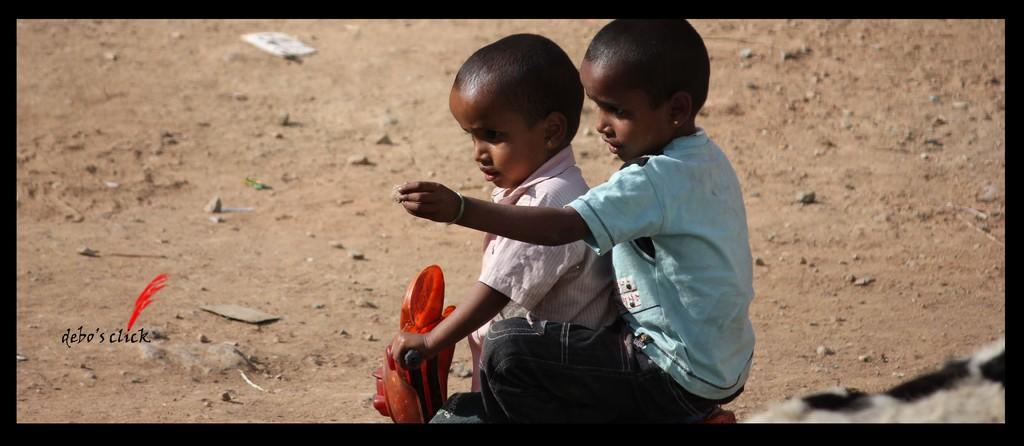What type of terrain is visible in the image? There is sand in the image. What other elements can be seen in the terrain? There are stones in the image. How many kids are present in the image? There are two kids in the image. What are the kids doing in the image? The kids are sitting on a cycle. What type of science experiment can be seen in the image? There is no science experiment present in the image; it features sand, stones, and two kids sitting on a cycle. 